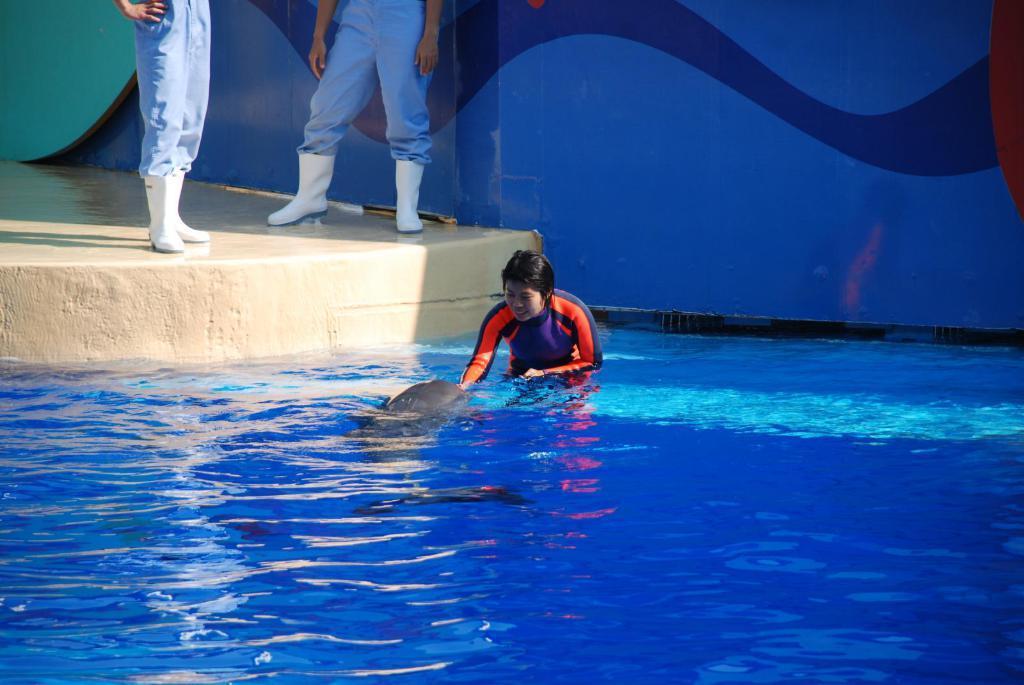Could you give a brief overview of what you see in this image? In this image, we can see a person and a whale in the water and in the background, there is a wall and we can see some other people on the floor. 